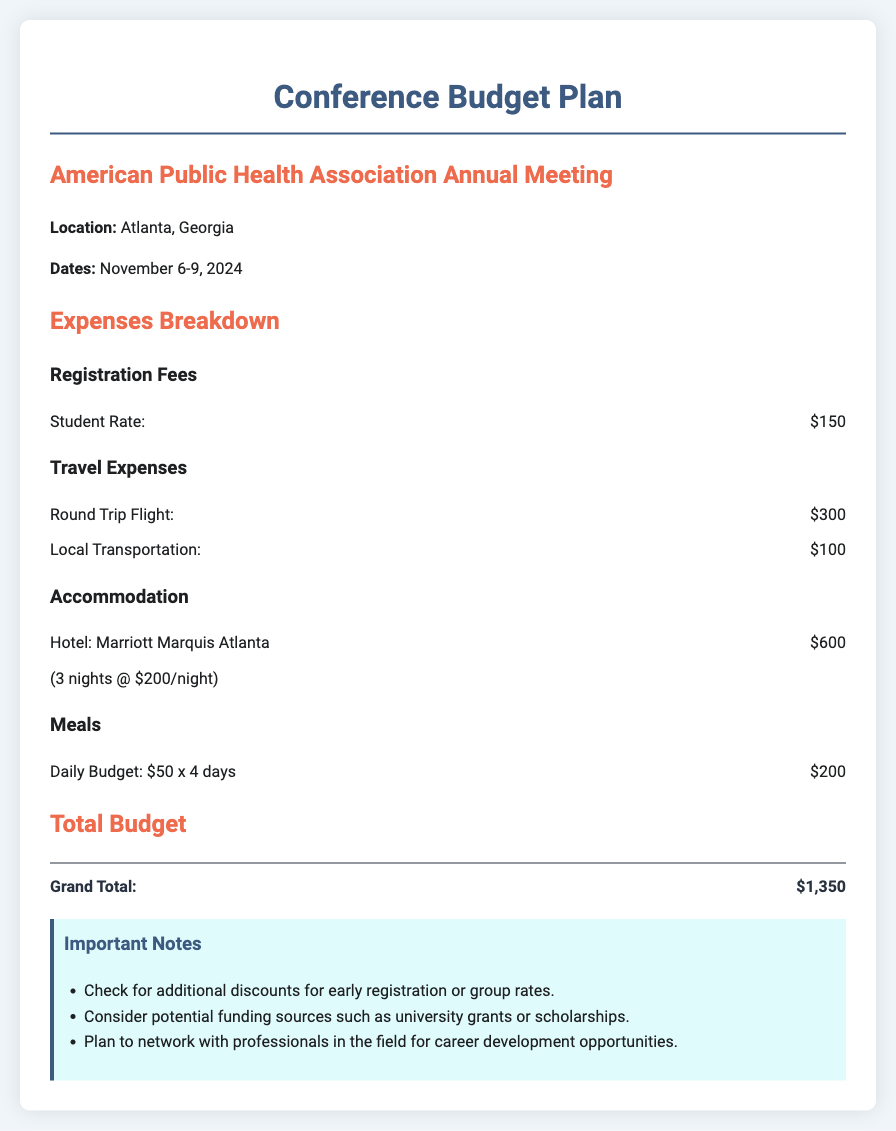What is the student registration fee? The student registration fee is listed under the Registration Fees section of the document.
Answer: $150 What are the dates of the conference? The dates of the conference are provided in the introduction section.
Answer: November 6-9, 2024 How much is the round trip flight? The cost for the round trip flight is detailed under Travel Expenses.
Answer: $300 How many nights will the accommodation be for? The accommodation cost mentions a specific hotel and the duration of stay.
Answer: 3 nights What is the daily budget for meals? The document specifies the daily meal budget in the Meals section.
Answer: $50 What is the grand total for the entire budget? The grand total is calculated at the end of the document based on all expenses listed.
Answer: $1,350 Which hotel will you be staying at? The document includes the name of the hotel in the Accommodation section.
Answer: Marriott Marquis Atlanta What is the budget for local transportation? The local transportation cost is mentioned under Travel Expenses.
Answer: $100 What is an important note regarding registration? Important notes provide guidance for potential savings and opportunities.
Answer: Check for additional discounts for early registration or group rates 